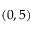Convert formula to latex. <formula><loc_0><loc_0><loc_500><loc_500>( 0 , 5 )</formula> 